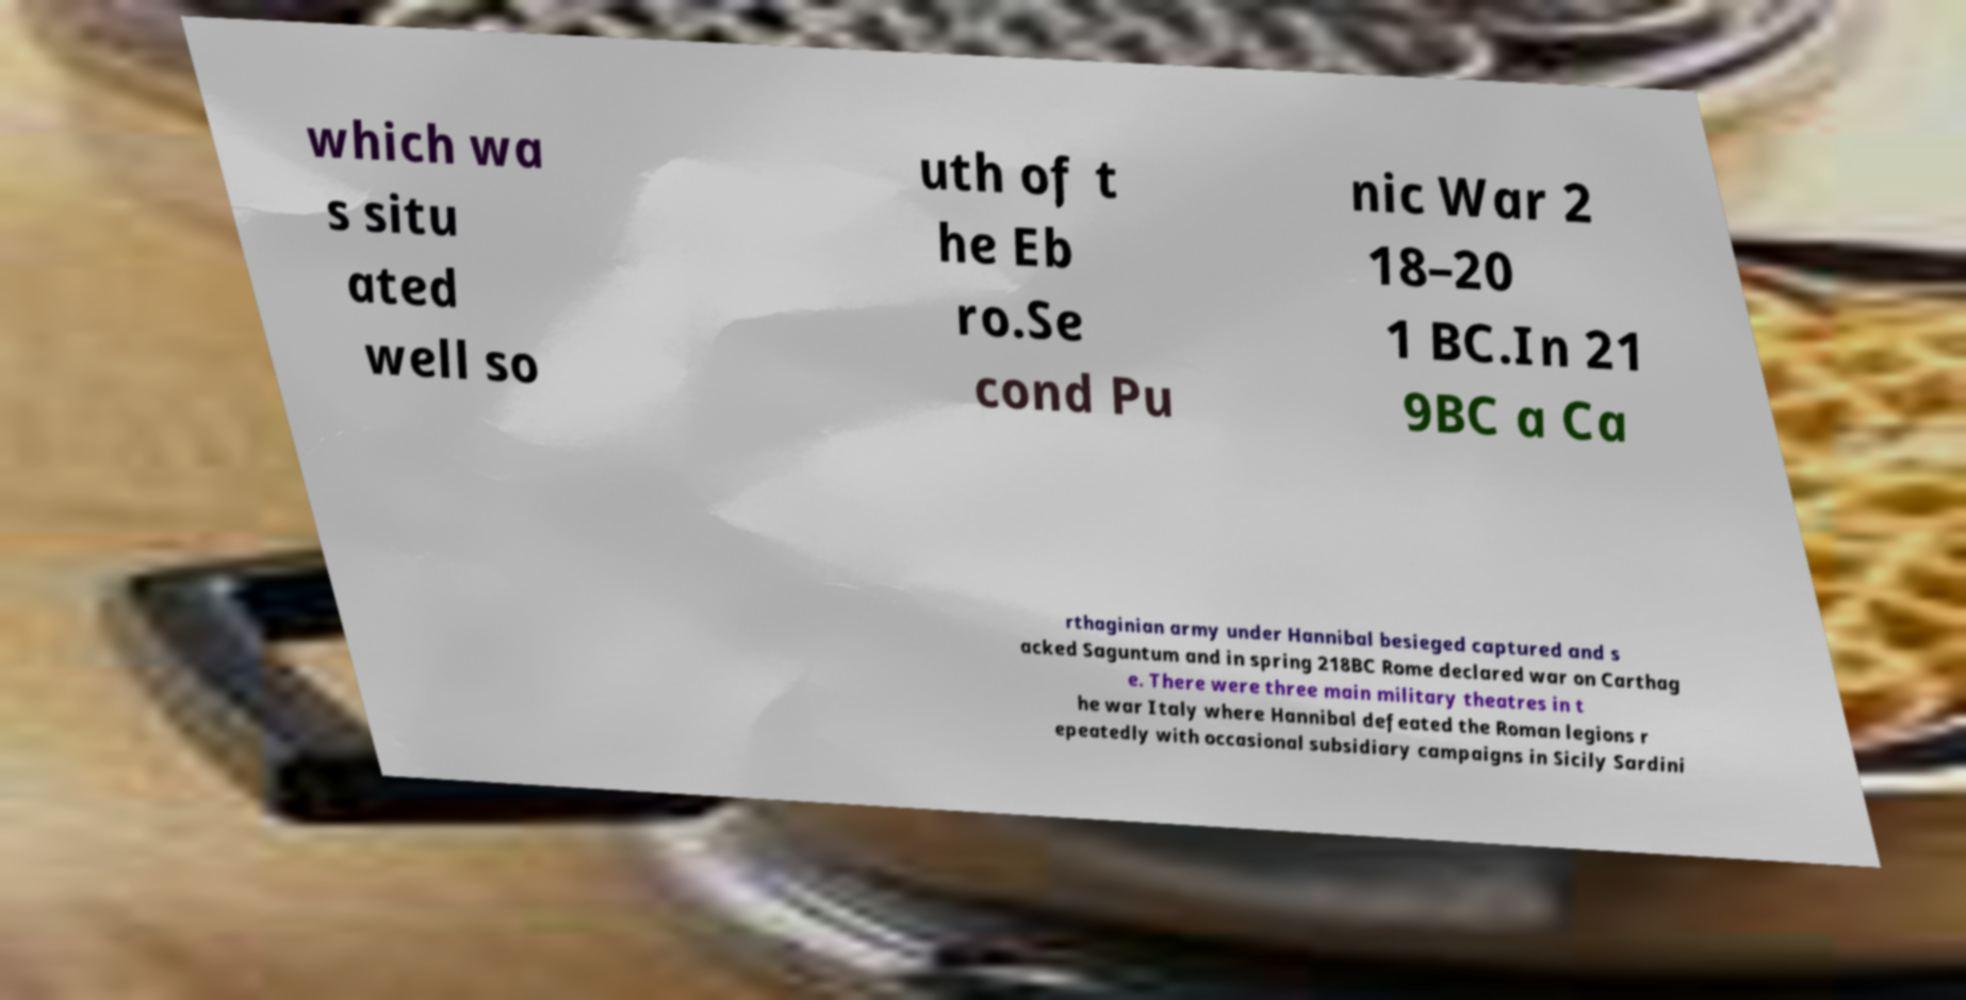Can you read and provide the text displayed in the image?This photo seems to have some interesting text. Can you extract and type it out for me? which wa s situ ated well so uth of t he Eb ro.Se cond Pu nic War 2 18–20 1 BC.In 21 9BC a Ca rthaginian army under Hannibal besieged captured and s acked Saguntum and in spring 218BC Rome declared war on Carthag e. There were three main military theatres in t he war Italy where Hannibal defeated the Roman legions r epeatedly with occasional subsidiary campaigns in Sicily Sardini 